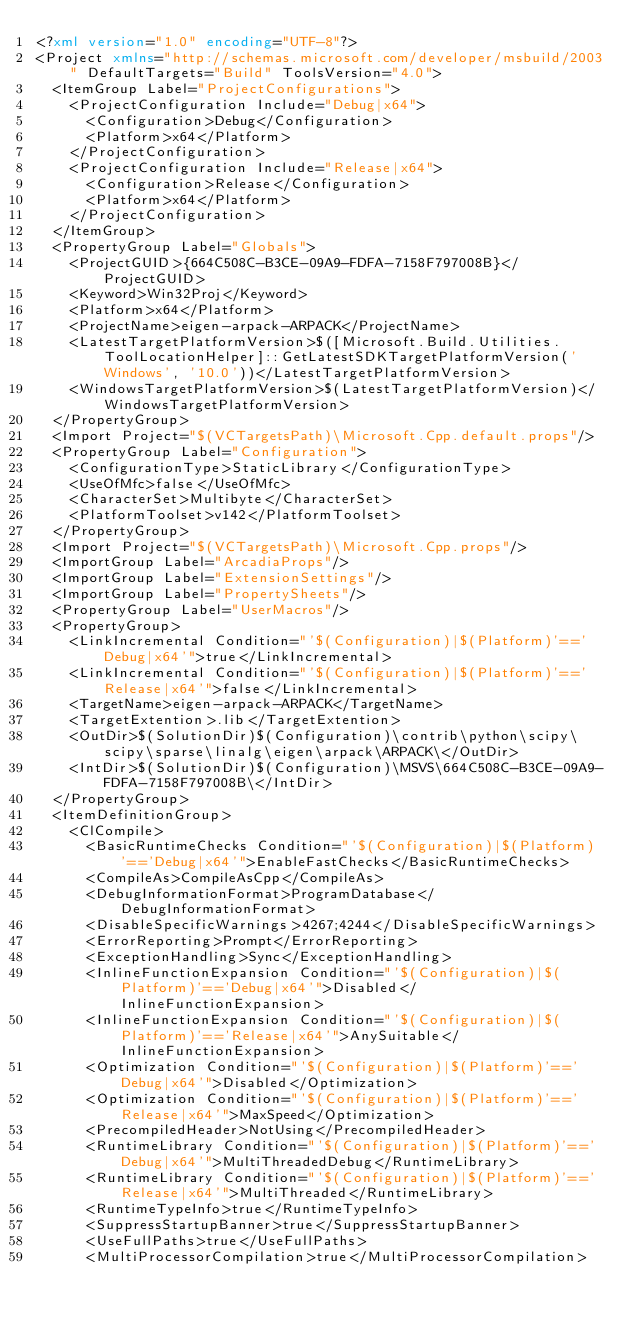<code> <loc_0><loc_0><loc_500><loc_500><_XML_><?xml version="1.0" encoding="UTF-8"?>
<Project xmlns="http://schemas.microsoft.com/developer/msbuild/2003" DefaultTargets="Build" ToolsVersion="4.0">
  <ItemGroup Label="ProjectConfigurations">
    <ProjectConfiguration Include="Debug|x64">
      <Configuration>Debug</Configuration>
      <Platform>x64</Platform>
    </ProjectConfiguration>
    <ProjectConfiguration Include="Release|x64">
      <Configuration>Release</Configuration>
      <Platform>x64</Platform>
    </ProjectConfiguration>
  </ItemGroup>
  <PropertyGroup Label="Globals">
    <ProjectGUID>{664C508C-B3CE-09A9-FDFA-7158F797008B}</ProjectGUID>
    <Keyword>Win32Proj</Keyword>
    <Platform>x64</Platform>
    <ProjectName>eigen-arpack-ARPACK</ProjectName>
    <LatestTargetPlatformVersion>$([Microsoft.Build.Utilities.ToolLocationHelper]::GetLatestSDKTargetPlatformVersion('Windows', '10.0'))</LatestTargetPlatformVersion>
    <WindowsTargetPlatformVersion>$(LatestTargetPlatformVersion)</WindowsTargetPlatformVersion>
  </PropertyGroup>
  <Import Project="$(VCTargetsPath)\Microsoft.Cpp.default.props"/>
  <PropertyGroup Label="Configuration">
    <ConfigurationType>StaticLibrary</ConfigurationType>
    <UseOfMfc>false</UseOfMfc>
    <CharacterSet>Multibyte</CharacterSet>
    <PlatformToolset>v142</PlatformToolset>
  </PropertyGroup>
  <Import Project="$(VCTargetsPath)\Microsoft.Cpp.props"/>
  <ImportGroup Label="ArcadiaProps"/>
  <ImportGroup Label="ExtensionSettings"/>
  <ImportGroup Label="PropertySheets"/>
  <PropertyGroup Label="UserMacros"/>
  <PropertyGroup>
    <LinkIncremental Condition="'$(Configuration)|$(Platform)'=='Debug|x64'">true</LinkIncremental>
    <LinkIncremental Condition="'$(Configuration)|$(Platform)'=='Release|x64'">false</LinkIncremental>
    <TargetName>eigen-arpack-ARPACK</TargetName>
    <TargetExtention>.lib</TargetExtention>
    <OutDir>$(SolutionDir)$(Configuration)\contrib\python\scipy\scipy\sparse\linalg\eigen\arpack\ARPACK\</OutDir>
    <IntDir>$(SolutionDir)$(Configuration)\MSVS\664C508C-B3CE-09A9-FDFA-7158F797008B\</IntDir>
  </PropertyGroup>
  <ItemDefinitionGroup>
    <ClCompile>
      <BasicRuntimeChecks Condition="'$(Configuration)|$(Platform)'=='Debug|x64'">EnableFastChecks</BasicRuntimeChecks>
      <CompileAs>CompileAsCpp</CompileAs>
      <DebugInformationFormat>ProgramDatabase</DebugInformationFormat>
      <DisableSpecificWarnings>4267;4244</DisableSpecificWarnings>
      <ErrorReporting>Prompt</ErrorReporting>
      <ExceptionHandling>Sync</ExceptionHandling>
      <InlineFunctionExpansion Condition="'$(Configuration)|$(Platform)'=='Debug|x64'">Disabled</InlineFunctionExpansion>
      <InlineFunctionExpansion Condition="'$(Configuration)|$(Platform)'=='Release|x64'">AnySuitable</InlineFunctionExpansion>
      <Optimization Condition="'$(Configuration)|$(Platform)'=='Debug|x64'">Disabled</Optimization>
      <Optimization Condition="'$(Configuration)|$(Platform)'=='Release|x64'">MaxSpeed</Optimization>
      <PrecompiledHeader>NotUsing</PrecompiledHeader>
      <RuntimeLibrary Condition="'$(Configuration)|$(Platform)'=='Debug|x64'">MultiThreadedDebug</RuntimeLibrary>
      <RuntimeLibrary Condition="'$(Configuration)|$(Platform)'=='Release|x64'">MultiThreaded</RuntimeLibrary>
      <RuntimeTypeInfo>true</RuntimeTypeInfo>
      <SuppressStartupBanner>true</SuppressStartupBanner>
      <UseFullPaths>true</UseFullPaths>
      <MultiProcessorCompilation>true</MultiProcessorCompilation></code> 